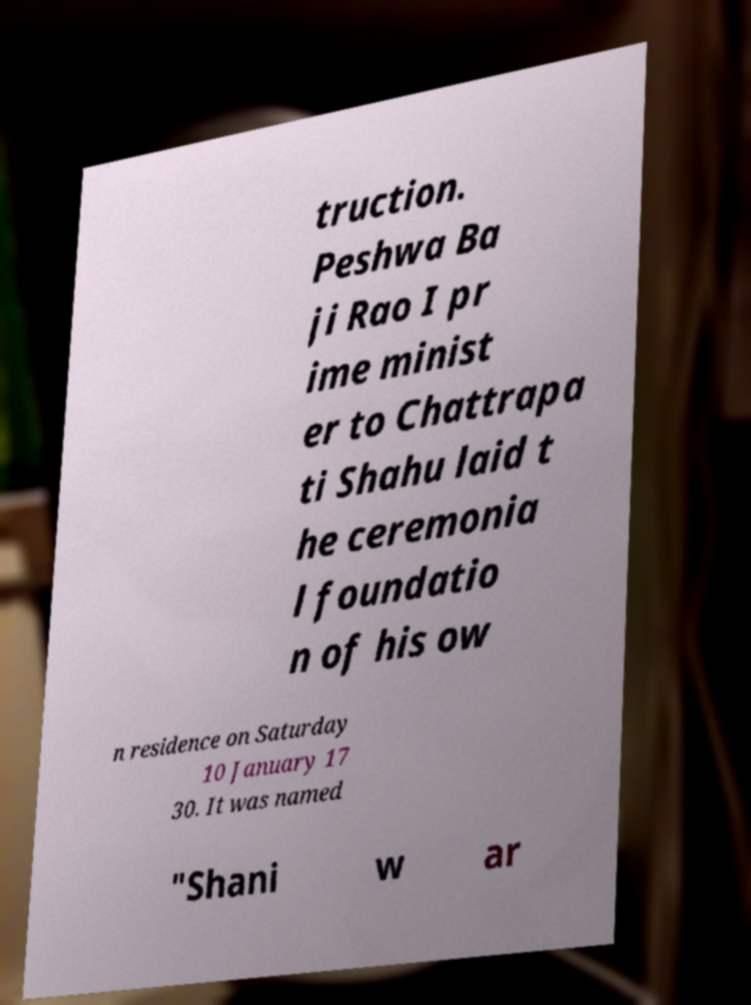Please identify and transcribe the text found in this image. truction. Peshwa Ba ji Rao I pr ime minist er to Chattrapa ti Shahu laid t he ceremonia l foundatio n of his ow n residence on Saturday 10 January 17 30. It was named "Shani w ar 